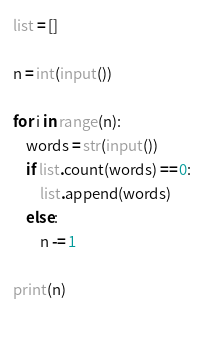<code> <loc_0><loc_0><loc_500><loc_500><_Python_>list = []

n = int(input())

for i in range(n):
    words = str(input())
    if list.count(words) == 0:
        list.append(words)
    else:
        n -= 1

print(n)
       
  </code> 